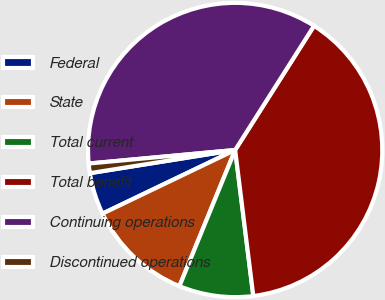Convert chart. <chart><loc_0><loc_0><loc_500><loc_500><pie_chart><fcel>Federal<fcel>State<fcel>Total current<fcel>Total benefit<fcel>Continuing operations<fcel>Discontinued operations<nl><fcel>4.6%<fcel>11.7%<fcel>8.15%<fcel>39.02%<fcel>35.47%<fcel>1.05%<nl></chart> 